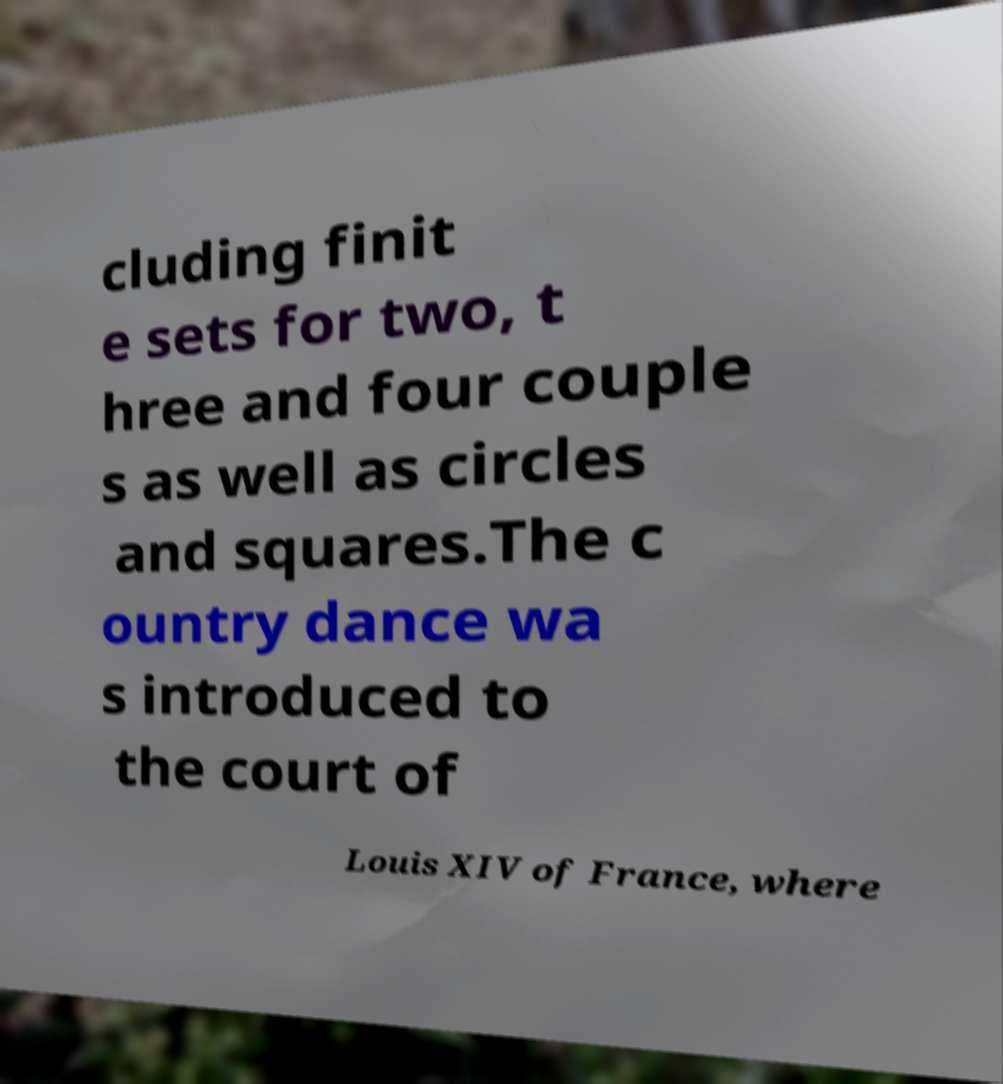Can you read and provide the text displayed in the image?This photo seems to have some interesting text. Can you extract and type it out for me? cluding finit e sets for two, t hree and four couple s as well as circles and squares.The c ountry dance wa s introduced to the court of Louis XIV of France, where 